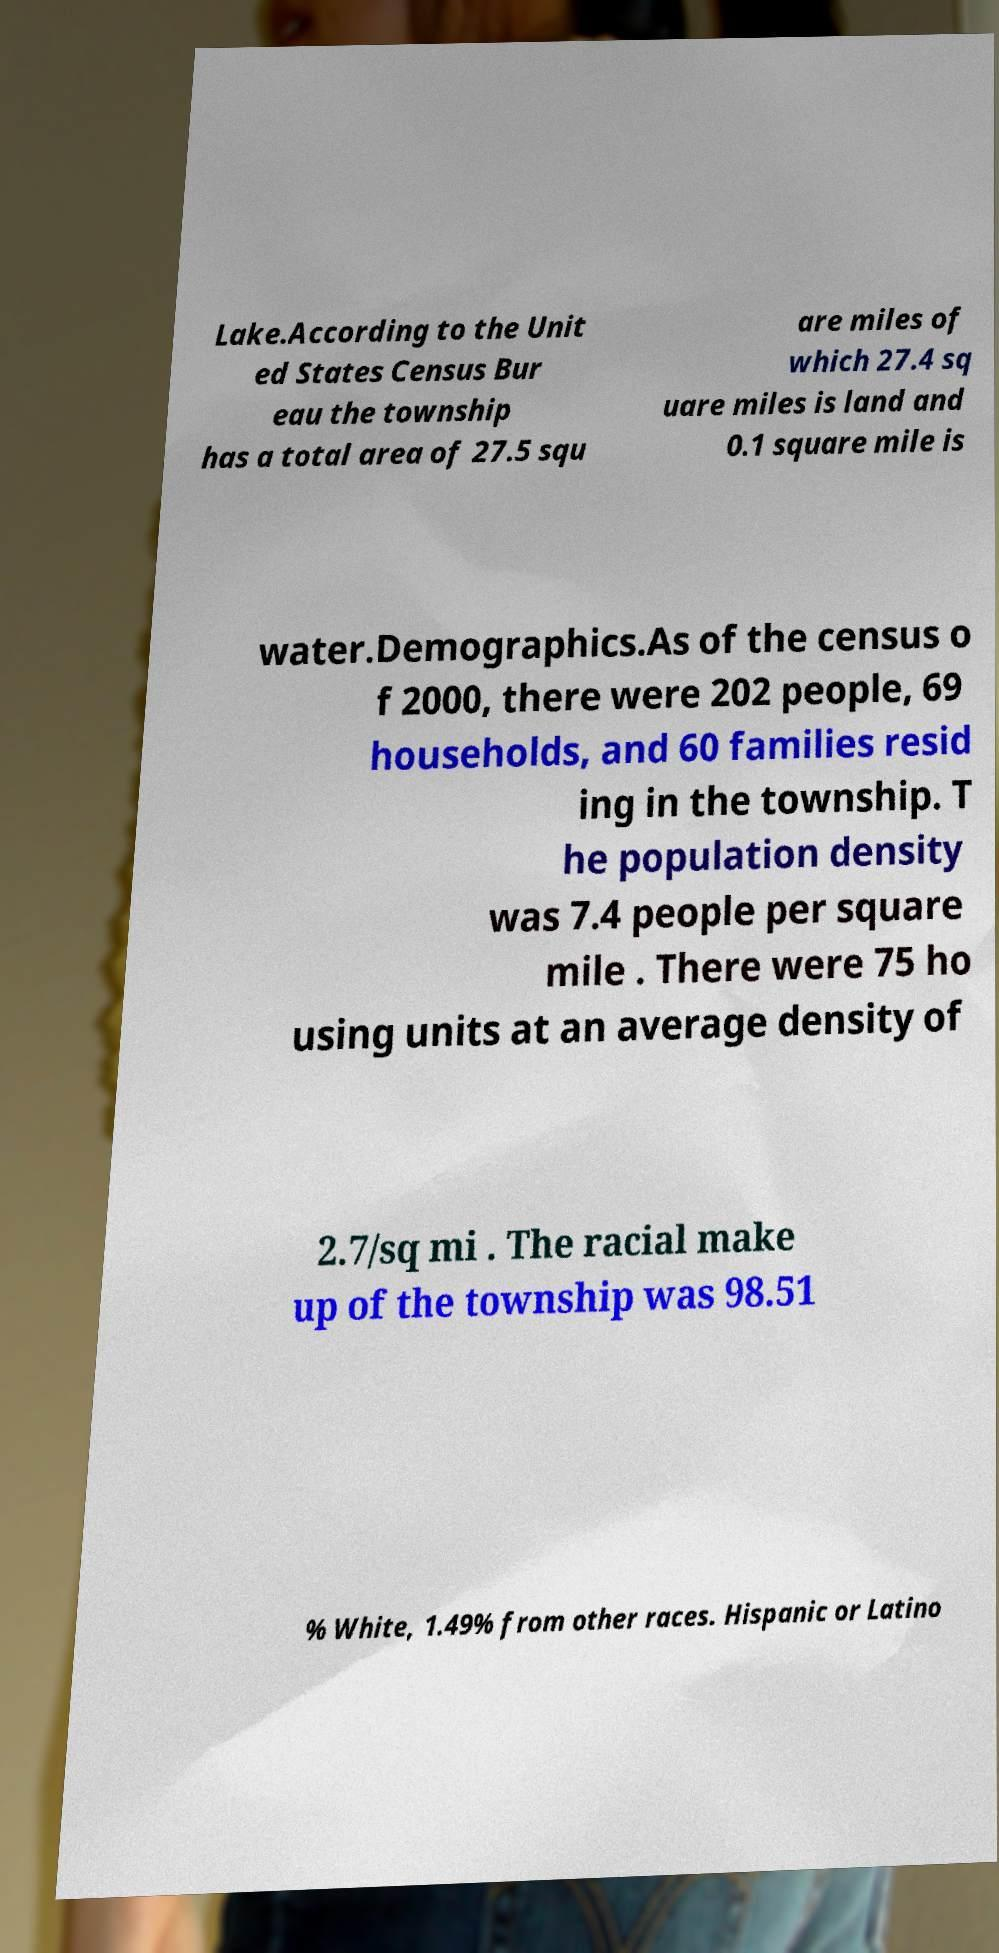For documentation purposes, I need the text within this image transcribed. Could you provide that? Lake.According to the Unit ed States Census Bur eau the township has a total area of 27.5 squ are miles of which 27.4 sq uare miles is land and 0.1 square mile is water.Demographics.As of the census o f 2000, there were 202 people, 69 households, and 60 families resid ing in the township. T he population density was 7.4 people per square mile . There were 75 ho using units at an average density of 2.7/sq mi . The racial make up of the township was 98.51 % White, 1.49% from other races. Hispanic or Latino 